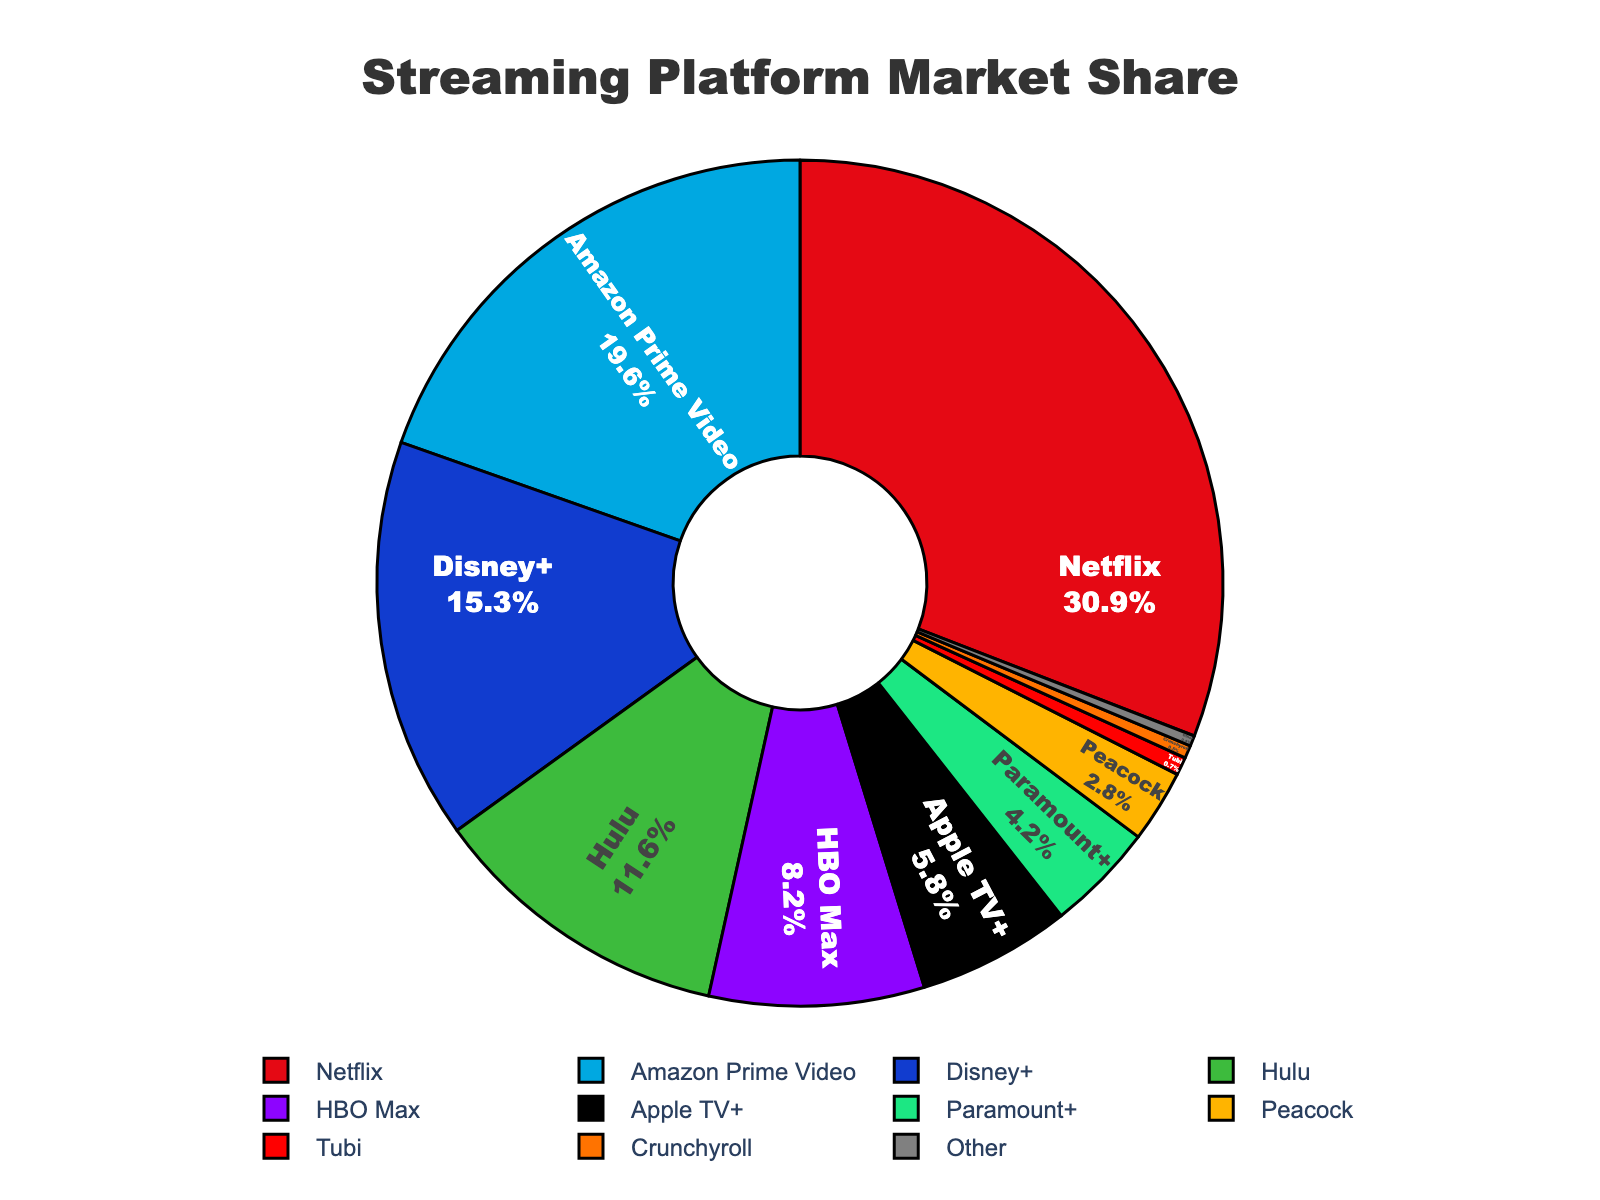Which streaming platform holds the largest market share? The pie chart shows that Netflix has the largest segment. By looking at the label, Netflix holds 31.2% of the market share.
Answer: Netflix How much larger is Netflix's market share compared to Amazon Prime Video's? The percentage for Netflix is 31.2% and Amazon Prime Video is 19.8%. Subtracting the two values: 31.2% - 19.8% = 11.4%.
Answer: 11.4% What is the combined market share of Hulu and Disney+? From the chart, Hulu has a market share of 11.7% and Disney+ has 15.5%. By adding these two figures: 11.7% + 15.5% = 27.2%.
Answer: 27.2% Which platform has a greater market share, Apple TV+ or HBO Max, and by how much? Apple TV+ has a market share of 5.9% and HBO Max has 8.3%. Comparing the two, HBO Max has a larger share by 2.4% (8.3% - 5.9%).
Answer: HBO Max by 2.4% What percentage of the market does the combined share of Peacock and Paramount+ represent? Peacock holds a 2.8% share and Paramount+ has 4.2%. Adding these two figures: 2.8% + 4.2% = 7%.
Answer: 7% How does the market share of other platforms compare to Tubi? From the pie chart, 'Other' has a market share of 0.4%. Tubi’s market share is 0.7%. Tubi's market share is 0.3% higher than 'Other' (0.7% - 0.4%).
Answer: Tubi by 0.3% Is Hulu's market share greater than or less than half of Netflix's market share? Hulu's market share is 11.7%, while half of Netflix's market share is 31.2% / 2 = 15.6%. Since 11.7% is less than 15.6%, Hulu's market share is less than half of Netflix's.
Answer: Less What total market share is controlled by streaming platforms other than Netflix, Amazon Prime Video, and Disney+? The sum of the market shares for platforms excluding Netflix, Amazon Prime Video, and Disney+ is 11.7 (Hulu) + 8.3 (HBO Max) + 5.9 (Apple TV+) + 4.2 (Paramount+) + 2.8 (Peacock) + 0.7 (Tubi) + 0.5 (Crunchyroll) + 0.4 (Other) = 34.5%.
Answer: 34.5% Which platform has the smallest market share and what is its value? The pie chart indicates Crunchyroll has the smallest market share, with a value of 0.5%.
Answer: Crunchyroll How much larger is the market share of Disney+ compared to Apple TV+? Disney+ holds 15.5% of the market while Apple TV+ holds 5.9%. Subtracting the smaller share from the larger share: 15.5% - 5.9% = 9.6%.
Answer: 9.6% 